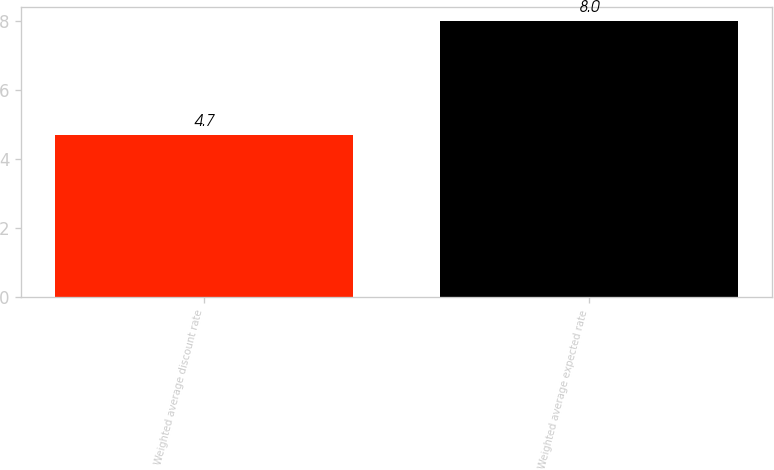Convert chart. <chart><loc_0><loc_0><loc_500><loc_500><bar_chart><fcel>Weighted average discount rate<fcel>Weighted average expected rate<nl><fcel>4.7<fcel>8<nl></chart> 